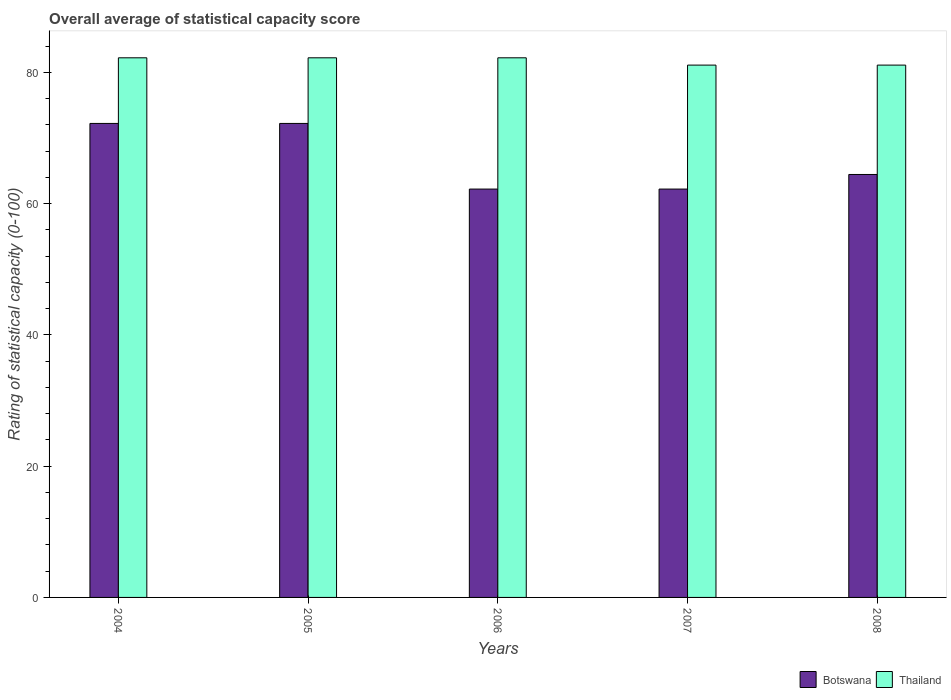How many different coloured bars are there?
Provide a short and direct response. 2. Are the number of bars per tick equal to the number of legend labels?
Make the answer very short. Yes. How many bars are there on the 2nd tick from the left?
Your response must be concise. 2. What is the label of the 4th group of bars from the left?
Provide a succinct answer. 2007. In how many cases, is the number of bars for a given year not equal to the number of legend labels?
Ensure brevity in your answer.  0. What is the rating of statistical capacity in Botswana in 2008?
Make the answer very short. 64.44. Across all years, what is the maximum rating of statistical capacity in Thailand?
Your answer should be compact. 82.22. Across all years, what is the minimum rating of statistical capacity in Thailand?
Offer a very short reply. 81.11. In which year was the rating of statistical capacity in Botswana maximum?
Offer a very short reply. 2004. In which year was the rating of statistical capacity in Thailand minimum?
Make the answer very short. 2007. What is the total rating of statistical capacity in Thailand in the graph?
Give a very brief answer. 408.89. What is the difference between the rating of statistical capacity in Botswana in 2005 and the rating of statistical capacity in Thailand in 2006?
Offer a terse response. -10. What is the average rating of statistical capacity in Botswana per year?
Keep it short and to the point. 66.67. In the year 2006, what is the difference between the rating of statistical capacity in Thailand and rating of statistical capacity in Botswana?
Keep it short and to the point. 20. In how many years, is the rating of statistical capacity in Botswana greater than 44?
Your answer should be compact. 5. What is the ratio of the rating of statistical capacity in Thailand in 2005 to that in 2006?
Offer a terse response. 1. Is the rating of statistical capacity in Thailand in 2005 less than that in 2006?
Your answer should be very brief. No. What is the difference between the highest and the lowest rating of statistical capacity in Thailand?
Offer a terse response. 1.11. In how many years, is the rating of statistical capacity in Botswana greater than the average rating of statistical capacity in Botswana taken over all years?
Offer a very short reply. 2. What does the 2nd bar from the left in 2008 represents?
Your answer should be very brief. Thailand. What does the 2nd bar from the right in 2004 represents?
Give a very brief answer. Botswana. How many years are there in the graph?
Provide a short and direct response. 5. Are the values on the major ticks of Y-axis written in scientific E-notation?
Give a very brief answer. No. Does the graph contain any zero values?
Make the answer very short. No. Does the graph contain grids?
Provide a succinct answer. No. Where does the legend appear in the graph?
Give a very brief answer. Bottom right. How are the legend labels stacked?
Provide a succinct answer. Horizontal. What is the title of the graph?
Offer a terse response. Overall average of statistical capacity score. What is the label or title of the X-axis?
Offer a terse response. Years. What is the label or title of the Y-axis?
Give a very brief answer. Rating of statistical capacity (0-100). What is the Rating of statistical capacity (0-100) in Botswana in 2004?
Ensure brevity in your answer.  72.22. What is the Rating of statistical capacity (0-100) of Thailand in 2004?
Offer a very short reply. 82.22. What is the Rating of statistical capacity (0-100) in Botswana in 2005?
Offer a very short reply. 72.22. What is the Rating of statistical capacity (0-100) in Thailand in 2005?
Offer a very short reply. 82.22. What is the Rating of statistical capacity (0-100) in Botswana in 2006?
Provide a short and direct response. 62.22. What is the Rating of statistical capacity (0-100) in Thailand in 2006?
Your response must be concise. 82.22. What is the Rating of statistical capacity (0-100) of Botswana in 2007?
Your answer should be compact. 62.22. What is the Rating of statistical capacity (0-100) of Thailand in 2007?
Ensure brevity in your answer.  81.11. What is the Rating of statistical capacity (0-100) in Botswana in 2008?
Your response must be concise. 64.44. What is the Rating of statistical capacity (0-100) of Thailand in 2008?
Keep it short and to the point. 81.11. Across all years, what is the maximum Rating of statistical capacity (0-100) in Botswana?
Your response must be concise. 72.22. Across all years, what is the maximum Rating of statistical capacity (0-100) of Thailand?
Keep it short and to the point. 82.22. Across all years, what is the minimum Rating of statistical capacity (0-100) of Botswana?
Your answer should be compact. 62.22. Across all years, what is the minimum Rating of statistical capacity (0-100) of Thailand?
Offer a very short reply. 81.11. What is the total Rating of statistical capacity (0-100) in Botswana in the graph?
Provide a succinct answer. 333.33. What is the total Rating of statistical capacity (0-100) of Thailand in the graph?
Provide a succinct answer. 408.89. What is the difference between the Rating of statistical capacity (0-100) in Botswana in 2004 and that in 2005?
Offer a very short reply. 0. What is the difference between the Rating of statistical capacity (0-100) in Thailand in 2004 and that in 2005?
Give a very brief answer. 0. What is the difference between the Rating of statistical capacity (0-100) of Botswana in 2004 and that in 2006?
Ensure brevity in your answer.  10. What is the difference between the Rating of statistical capacity (0-100) of Thailand in 2004 and that in 2006?
Provide a succinct answer. 0. What is the difference between the Rating of statistical capacity (0-100) of Botswana in 2004 and that in 2007?
Give a very brief answer. 10. What is the difference between the Rating of statistical capacity (0-100) of Thailand in 2004 and that in 2007?
Provide a succinct answer. 1.11. What is the difference between the Rating of statistical capacity (0-100) in Botswana in 2004 and that in 2008?
Your answer should be compact. 7.78. What is the difference between the Rating of statistical capacity (0-100) in Thailand in 2004 and that in 2008?
Your answer should be very brief. 1.11. What is the difference between the Rating of statistical capacity (0-100) in Thailand in 2005 and that in 2006?
Your answer should be very brief. 0. What is the difference between the Rating of statistical capacity (0-100) in Botswana in 2005 and that in 2007?
Your answer should be compact. 10. What is the difference between the Rating of statistical capacity (0-100) in Thailand in 2005 and that in 2007?
Keep it short and to the point. 1.11. What is the difference between the Rating of statistical capacity (0-100) of Botswana in 2005 and that in 2008?
Give a very brief answer. 7.78. What is the difference between the Rating of statistical capacity (0-100) in Thailand in 2005 and that in 2008?
Your answer should be compact. 1.11. What is the difference between the Rating of statistical capacity (0-100) in Botswana in 2006 and that in 2007?
Make the answer very short. 0. What is the difference between the Rating of statistical capacity (0-100) in Botswana in 2006 and that in 2008?
Provide a succinct answer. -2.22. What is the difference between the Rating of statistical capacity (0-100) in Thailand in 2006 and that in 2008?
Provide a short and direct response. 1.11. What is the difference between the Rating of statistical capacity (0-100) of Botswana in 2007 and that in 2008?
Ensure brevity in your answer.  -2.22. What is the difference between the Rating of statistical capacity (0-100) of Botswana in 2004 and the Rating of statistical capacity (0-100) of Thailand in 2005?
Your answer should be compact. -10. What is the difference between the Rating of statistical capacity (0-100) in Botswana in 2004 and the Rating of statistical capacity (0-100) in Thailand in 2006?
Your answer should be compact. -10. What is the difference between the Rating of statistical capacity (0-100) of Botswana in 2004 and the Rating of statistical capacity (0-100) of Thailand in 2007?
Ensure brevity in your answer.  -8.89. What is the difference between the Rating of statistical capacity (0-100) of Botswana in 2004 and the Rating of statistical capacity (0-100) of Thailand in 2008?
Your response must be concise. -8.89. What is the difference between the Rating of statistical capacity (0-100) in Botswana in 2005 and the Rating of statistical capacity (0-100) in Thailand in 2007?
Give a very brief answer. -8.89. What is the difference between the Rating of statistical capacity (0-100) in Botswana in 2005 and the Rating of statistical capacity (0-100) in Thailand in 2008?
Offer a terse response. -8.89. What is the difference between the Rating of statistical capacity (0-100) of Botswana in 2006 and the Rating of statistical capacity (0-100) of Thailand in 2007?
Give a very brief answer. -18.89. What is the difference between the Rating of statistical capacity (0-100) of Botswana in 2006 and the Rating of statistical capacity (0-100) of Thailand in 2008?
Your answer should be compact. -18.89. What is the difference between the Rating of statistical capacity (0-100) of Botswana in 2007 and the Rating of statistical capacity (0-100) of Thailand in 2008?
Give a very brief answer. -18.89. What is the average Rating of statistical capacity (0-100) of Botswana per year?
Give a very brief answer. 66.67. What is the average Rating of statistical capacity (0-100) in Thailand per year?
Give a very brief answer. 81.78. In the year 2004, what is the difference between the Rating of statistical capacity (0-100) in Botswana and Rating of statistical capacity (0-100) in Thailand?
Provide a succinct answer. -10. In the year 2005, what is the difference between the Rating of statistical capacity (0-100) in Botswana and Rating of statistical capacity (0-100) in Thailand?
Your response must be concise. -10. In the year 2007, what is the difference between the Rating of statistical capacity (0-100) of Botswana and Rating of statistical capacity (0-100) of Thailand?
Your response must be concise. -18.89. In the year 2008, what is the difference between the Rating of statistical capacity (0-100) in Botswana and Rating of statistical capacity (0-100) in Thailand?
Your response must be concise. -16.67. What is the ratio of the Rating of statistical capacity (0-100) of Botswana in 2004 to that in 2006?
Keep it short and to the point. 1.16. What is the ratio of the Rating of statistical capacity (0-100) of Botswana in 2004 to that in 2007?
Your answer should be very brief. 1.16. What is the ratio of the Rating of statistical capacity (0-100) of Thailand in 2004 to that in 2007?
Provide a succinct answer. 1.01. What is the ratio of the Rating of statistical capacity (0-100) in Botswana in 2004 to that in 2008?
Provide a succinct answer. 1.12. What is the ratio of the Rating of statistical capacity (0-100) of Thailand in 2004 to that in 2008?
Ensure brevity in your answer.  1.01. What is the ratio of the Rating of statistical capacity (0-100) in Botswana in 2005 to that in 2006?
Offer a very short reply. 1.16. What is the ratio of the Rating of statistical capacity (0-100) of Botswana in 2005 to that in 2007?
Keep it short and to the point. 1.16. What is the ratio of the Rating of statistical capacity (0-100) of Thailand in 2005 to that in 2007?
Offer a terse response. 1.01. What is the ratio of the Rating of statistical capacity (0-100) in Botswana in 2005 to that in 2008?
Ensure brevity in your answer.  1.12. What is the ratio of the Rating of statistical capacity (0-100) of Thailand in 2005 to that in 2008?
Provide a succinct answer. 1.01. What is the ratio of the Rating of statistical capacity (0-100) of Botswana in 2006 to that in 2007?
Offer a very short reply. 1. What is the ratio of the Rating of statistical capacity (0-100) in Thailand in 2006 to that in 2007?
Your response must be concise. 1.01. What is the ratio of the Rating of statistical capacity (0-100) of Botswana in 2006 to that in 2008?
Offer a terse response. 0.97. What is the ratio of the Rating of statistical capacity (0-100) in Thailand in 2006 to that in 2008?
Your answer should be compact. 1.01. What is the ratio of the Rating of statistical capacity (0-100) of Botswana in 2007 to that in 2008?
Offer a very short reply. 0.97. What is the ratio of the Rating of statistical capacity (0-100) in Thailand in 2007 to that in 2008?
Provide a short and direct response. 1. What is the difference between the highest and the second highest Rating of statistical capacity (0-100) in Botswana?
Your response must be concise. 0. What is the difference between the highest and the second highest Rating of statistical capacity (0-100) in Thailand?
Provide a succinct answer. 0. What is the difference between the highest and the lowest Rating of statistical capacity (0-100) of Thailand?
Offer a very short reply. 1.11. 